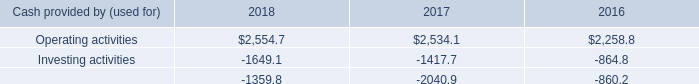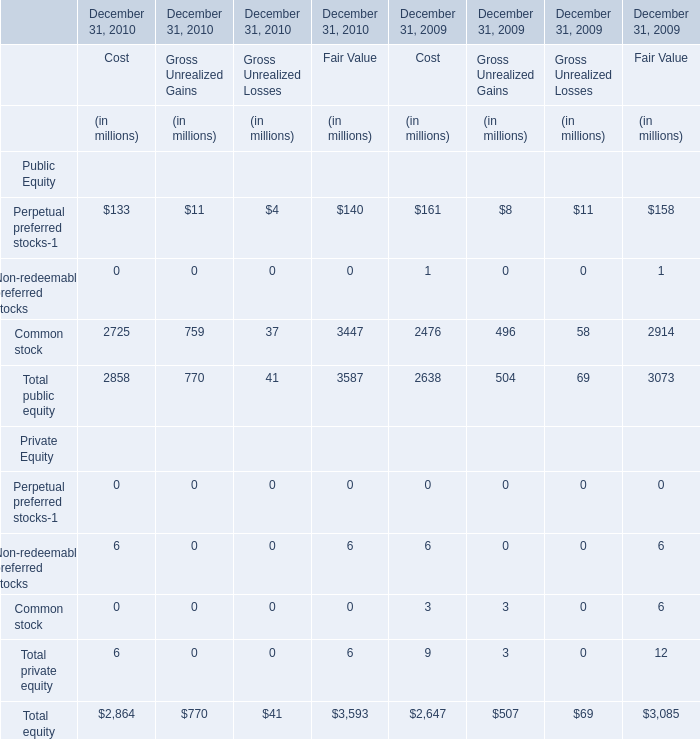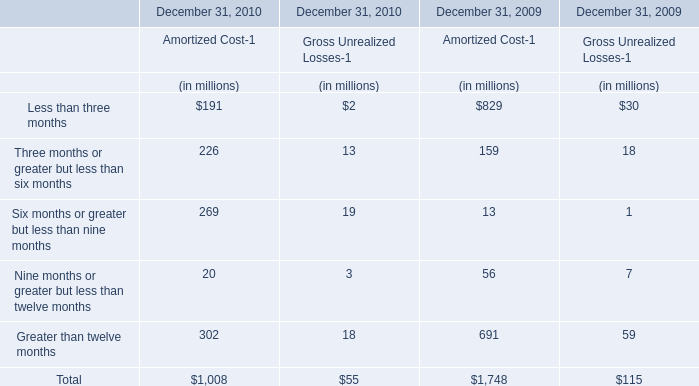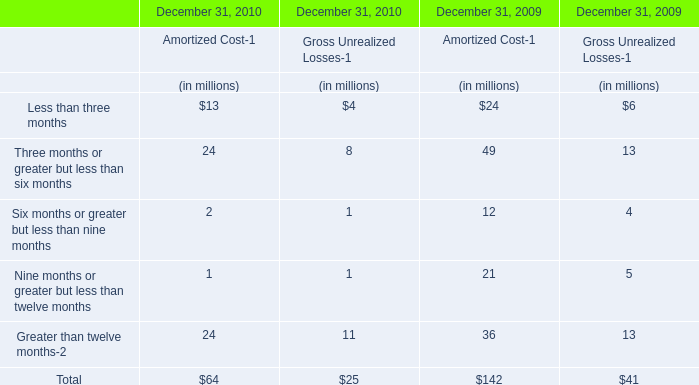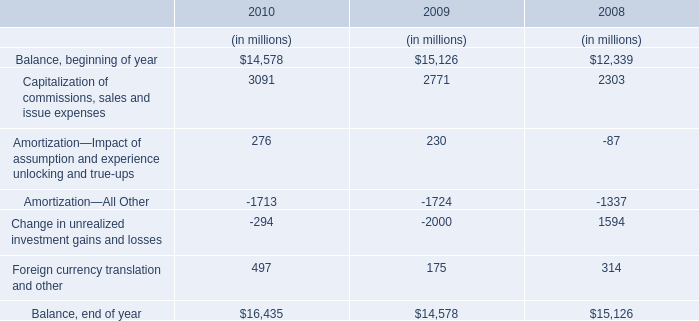What is the growing rate of total equity in the year with the most common stock of public equity for fair value? 
Computations: ((3587 - 3073) / 3073)
Answer: 0.16726. 